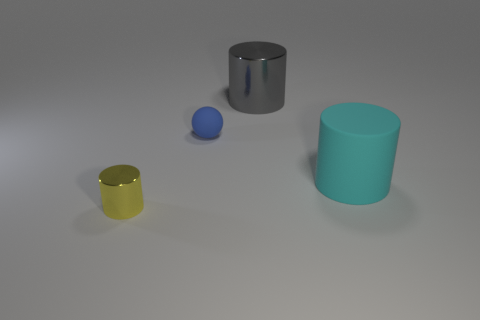Subtract all small cylinders. How many cylinders are left? 2 Add 3 large gray metallic cylinders. How many objects exist? 7 Subtract all balls. How many objects are left? 3 Subtract all yellow cylinders. How many cylinders are left? 2 Add 4 cyan cylinders. How many cyan cylinders are left? 5 Add 3 green matte cylinders. How many green matte cylinders exist? 3 Subtract 1 yellow cylinders. How many objects are left? 3 Subtract 1 spheres. How many spheres are left? 0 Subtract all yellow balls. Subtract all green cylinders. How many balls are left? 1 Subtract all yellow cylinders. Subtract all large purple rubber cylinders. How many objects are left? 3 